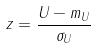Convert formula to latex. <formula><loc_0><loc_0><loc_500><loc_500>z = \frac { U - m _ { U } } { \sigma _ { U } }</formula> 